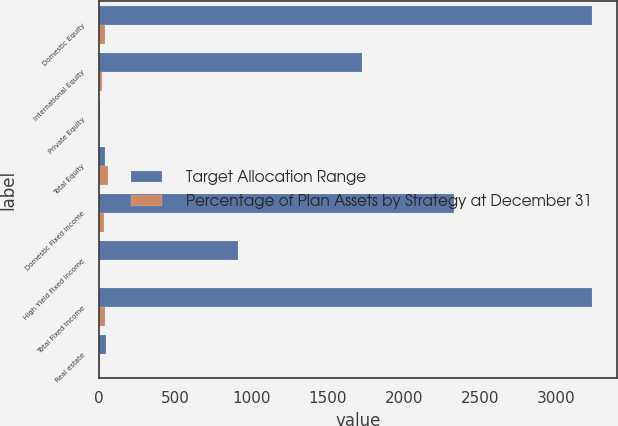<chart> <loc_0><loc_0><loc_500><loc_500><stacked_bar_chart><ecel><fcel>Domestic Equity<fcel>International Equity<fcel>Private Equity<fcel>Total Equity<fcel>Domestic Fixed Income<fcel>High Yield Fixed Income<fcel>Total Fixed Income<fcel>Real estate<nl><fcel>Target Allocation Range<fcel>3238<fcel>1723<fcel>8<fcel>39<fcel>2328<fcel>911<fcel>3239<fcel>46<nl><fcel>Percentage of Plan Assets by Strategy at December 31<fcel>39<fcel>18<fcel>2<fcel>59<fcel>29<fcel>6<fcel>35<fcel>5<nl></chart> 